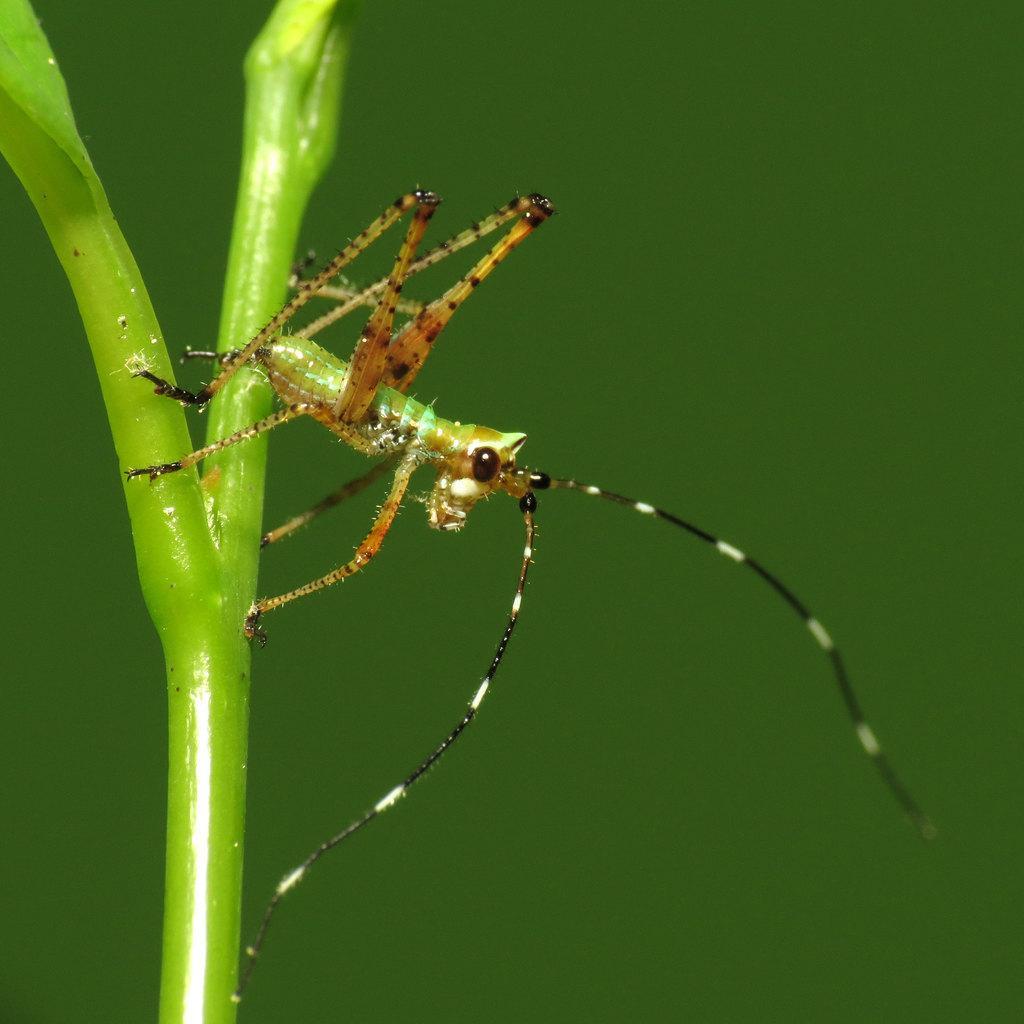In one or two sentences, can you explain what this image depicts? In this picture there is an insect standing on a green color object. 